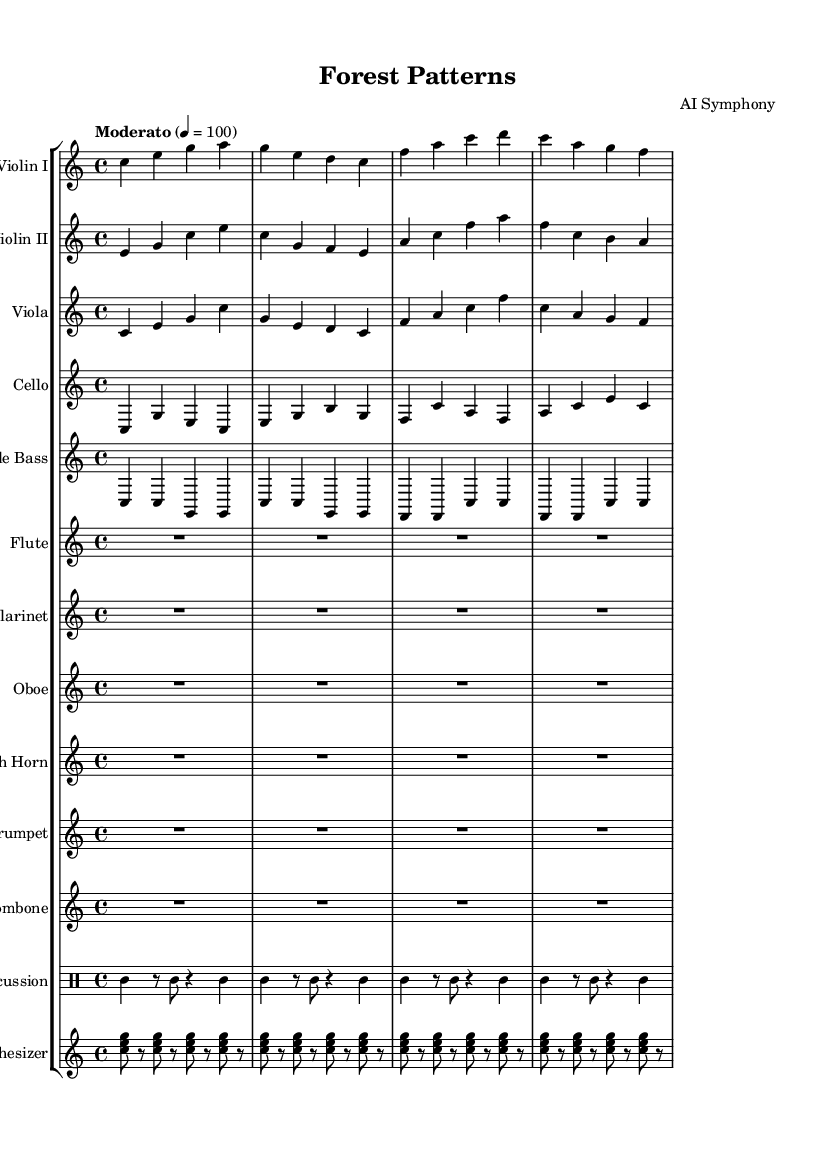What is the key signature of this music? The key signature is C major, which has no sharps or flats.
Answer: C major What is the time signature of the piece? The time signature is indicated as 4/4, meaning there are four beats in each measure.
Answer: 4/4 What is the tempo marking given for the symphony? The tempo marking is "Moderato," suggesting a moderate speed for the performance.
Answer: Moderato How many instruments are included in this symphony? There are a total of 12 instrument parts listed in the score.
Answer: 12 What kind of electronic element is incorporated into this symphony? A synthesizer is included, specifically with chords in its notation.
Answer: Synthesizer Which instruments have rest measures (indicated by R1*4)? The flute, clarinet, oboe, and french horn all have measures of rest for four beats.
Answer: Flute, Clarinet, Oboe, French Horn Which instrument plays the lowest pitch in the score? The double bass typically plays the lowest pitch due to its range and notation.
Answer: Double Bass 